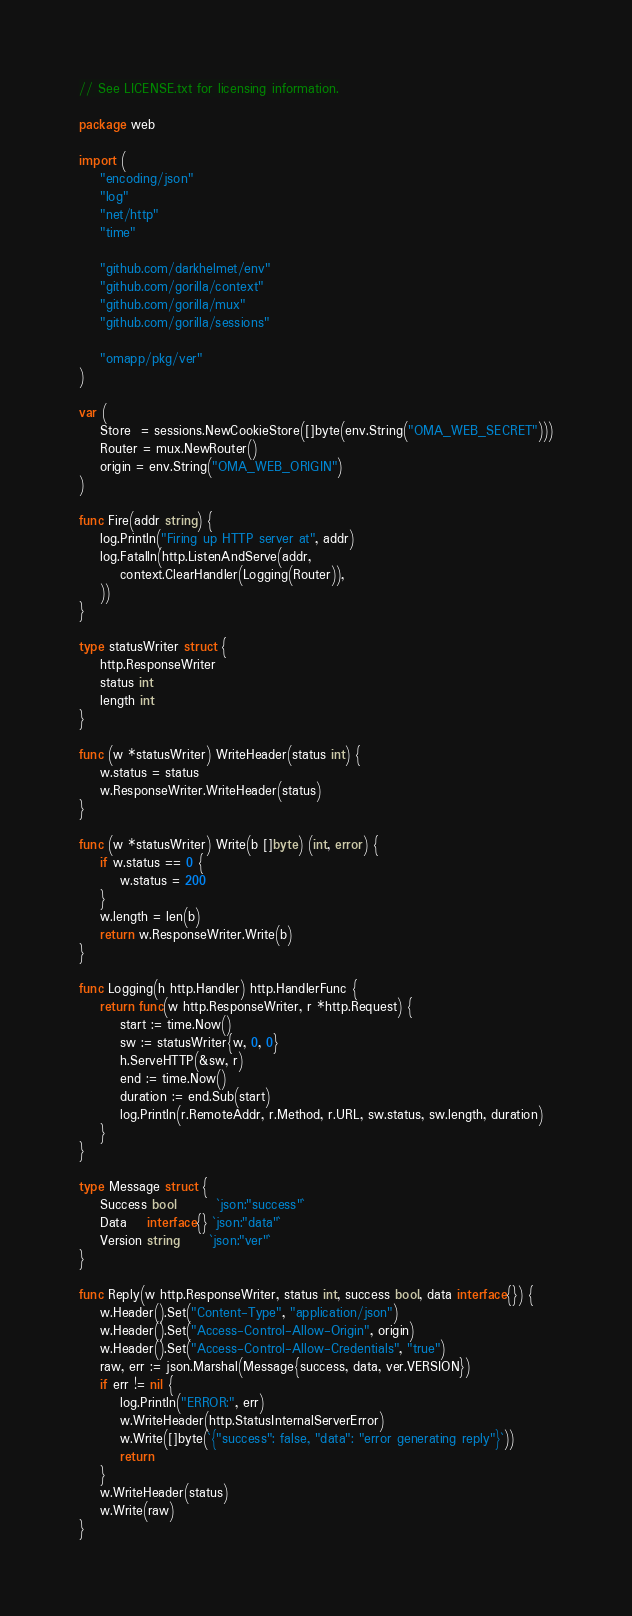<code> <loc_0><loc_0><loc_500><loc_500><_Go_>// See LICENSE.txt for licensing information.

package web

import (
	"encoding/json"
	"log"
	"net/http"
	"time"

	"github.com/darkhelmet/env"
	"github.com/gorilla/context"
	"github.com/gorilla/mux"
	"github.com/gorilla/sessions"

	"omapp/pkg/ver"
)

var (
	Store  = sessions.NewCookieStore([]byte(env.String("OMA_WEB_SECRET")))
	Router = mux.NewRouter()
	origin = env.String("OMA_WEB_ORIGIN")
)

func Fire(addr string) {
	log.Println("Firing up HTTP server at", addr)
	log.Fatalln(http.ListenAndServe(addr,
		context.ClearHandler(Logging(Router)),
	))
}

type statusWriter struct {
	http.ResponseWriter
	status int
	length int
}

func (w *statusWriter) WriteHeader(status int) {
	w.status = status
	w.ResponseWriter.WriteHeader(status)
}

func (w *statusWriter) Write(b []byte) (int, error) {
	if w.status == 0 {
		w.status = 200
	}
	w.length = len(b)
	return w.ResponseWriter.Write(b)
}

func Logging(h http.Handler) http.HandlerFunc {
	return func(w http.ResponseWriter, r *http.Request) {
		start := time.Now()
		sw := statusWriter{w, 0, 0}
		h.ServeHTTP(&sw, r)
		end := time.Now()
		duration := end.Sub(start)
		log.Println(r.RemoteAddr, r.Method, r.URL, sw.status, sw.length, duration)
	}
}

type Message struct {
	Success bool        `json:"success"`
	Data    interface{} `json:"data"`
	Version string      `json:"ver"`
}

func Reply(w http.ResponseWriter, status int, success bool, data interface{}) {
	w.Header().Set("Content-Type", "application/json")
	w.Header().Set("Access-Control-Allow-Origin", origin)
	w.Header().Set("Access-Control-Allow-Credentials", "true")
	raw, err := json.Marshal(Message{success, data, ver.VERSION})
	if err != nil {
		log.Println("ERROR:", err)
		w.WriteHeader(http.StatusInternalServerError)
		w.Write([]byte(`{"success": false, "data": "error generating reply"}`))
		return
	}
	w.WriteHeader(status)
	w.Write(raw)
}
</code> 